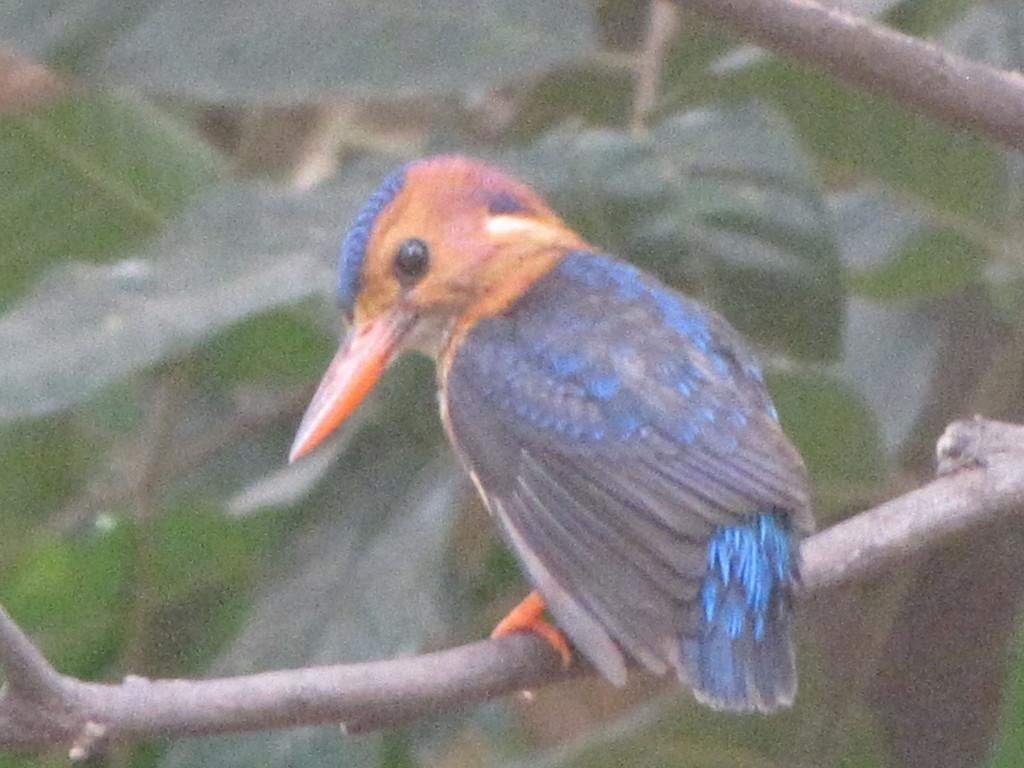What type of animal can be seen in the image? There is a bird in the image. Where is the bird located? The bird is standing on a tree branch. What can be seen in the background of the image? There are leaves visible in the background of the image. What type of hair can be seen on the bird in the image? There is no hair visible on the bird in the image; birds do not have hair. 